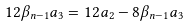Convert formula to latex. <formula><loc_0><loc_0><loc_500><loc_500>1 2 \beta _ { n - 1 } a _ { 3 } = 1 2 a _ { 2 } - 8 \beta _ { n - 1 } a _ { 3 }</formula> 